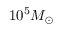<formula> <loc_0><loc_0><loc_500><loc_500>1 0 ^ { 5 } M _ { \odot }</formula> 